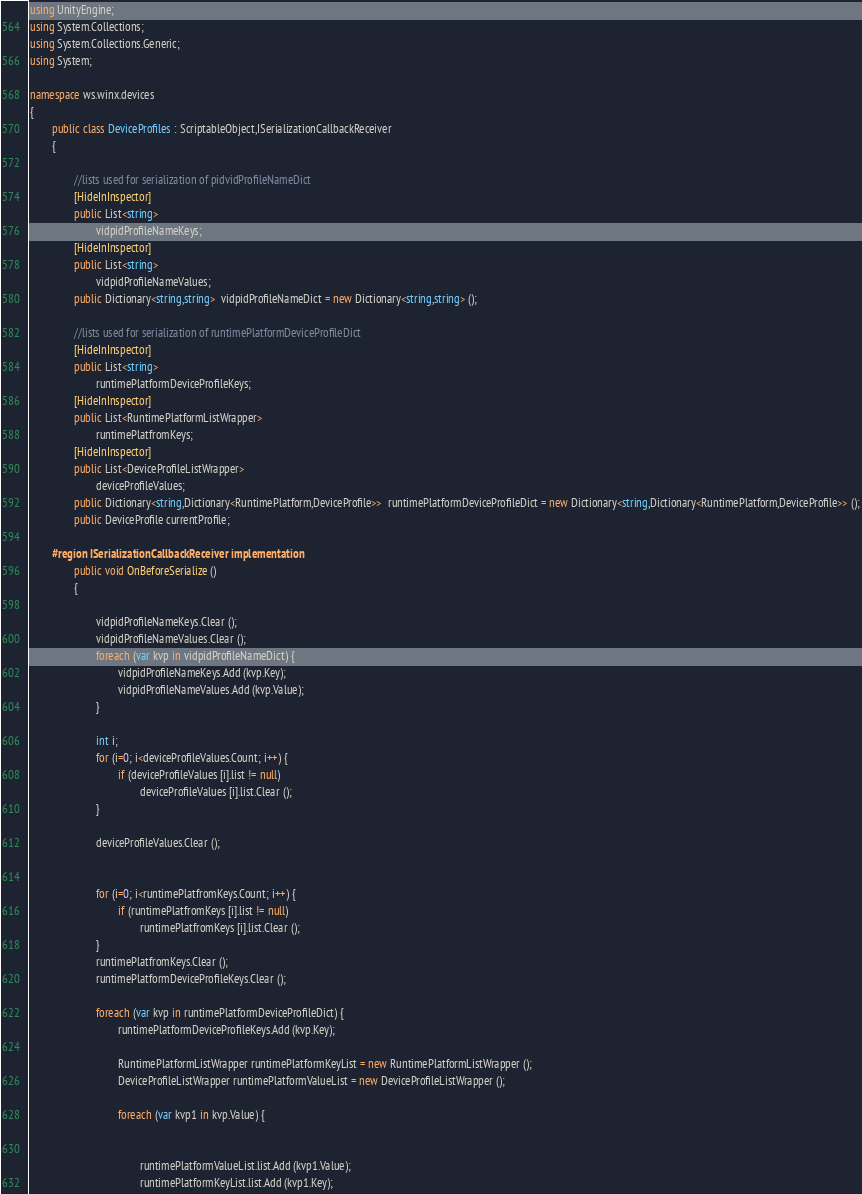Convert code to text. <code><loc_0><loc_0><loc_500><loc_500><_C#_>using UnityEngine;
using System.Collections;
using System.Collections.Generic;
using System;

namespace ws.winx.devices
{
		public class DeviceProfiles : ScriptableObject,ISerializationCallbackReceiver
		{

				//lists used for serialization of pidvidProfileNameDict
				[HideInInspector]
				public List<string>
						vidpidProfileNameKeys;
				[HideInInspector]
				public List<string>
						vidpidProfileNameValues;
				public Dictionary<string,string>  vidpidProfileNameDict = new Dictionary<string,string> ();

				//lists used for serialization of runtimePlatformDeviceProfileDict
				[HideInInspector]
				public List<string>
						runtimePlatformDeviceProfileKeys;
				[HideInInspector]
				public List<RuntimePlatformListWrapper>
						runtimePlatfromKeys;
				[HideInInspector]
				public List<DeviceProfileListWrapper>
						deviceProfileValues;
				public Dictionary<string,Dictionary<RuntimePlatform,DeviceProfile>>  runtimePlatformDeviceProfileDict = new Dictionary<string,Dictionary<RuntimePlatform,DeviceProfile>> ();
				public DeviceProfile currentProfile;

		#region ISerializationCallbackReceiver implementation
				public void OnBeforeSerialize ()
				{
						
						vidpidProfileNameKeys.Clear ();
						vidpidProfileNameValues.Clear ();
						foreach (var kvp in vidpidProfileNameDict) {
								vidpidProfileNameKeys.Add (kvp.Key);
								vidpidProfileNameValues.Add (kvp.Value);
						}

						int i;
						for (i=0; i<deviceProfileValues.Count; i++) {
								if (deviceProfileValues [i].list != null)
										deviceProfileValues [i].list.Clear ();
						}

						deviceProfileValues.Clear ();


						for (i=0; i<runtimePlatfromKeys.Count; i++) {
								if (runtimePlatfromKeys [i].list != null)
										runtimePlatfromKeys [i].list.Clear ();
						}
						runtimePlatfromKeys.Clear ();
						runtimePlatformDeviceProfileKeys.Clear ();

						foreach (var kvp in runtimePlatformDeviceProfileDict) {
								runtimePlatformDeviceProfileKeys.Add (kvp.Key);

								RuntimePlatformListWrapper runtimePlatformKeyList = new RuntimePlatformListWrapper ();
								DeviceProfileListWrapper runtimePlatformValueList = new DeviceProfileListWrapper ();

								foreach (var kvp1 in kvp.Value) {


										runtimePlatformValueList.list.Add (kvp1.Value);
										runtimePlatformKeyList.list.Add (kvp1.Key);</code> 